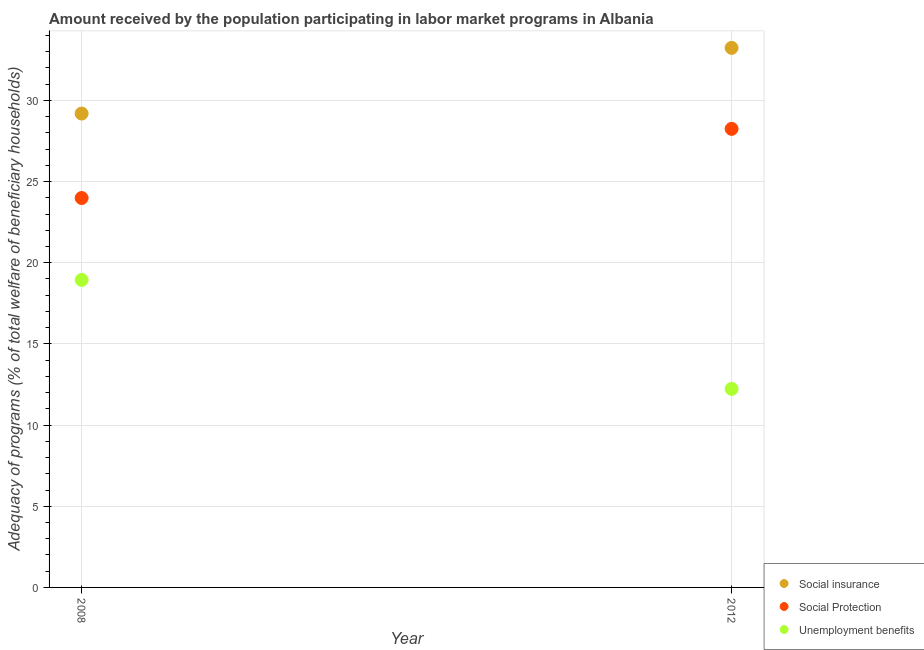What is the amount received by the population participating in social insurance programs in 2008?
Your answer should be compact. 29.19. Across all years, what is the maximum amount received by the population participating in social insurance programs?
Give a very brief answer. 33.23. Across all years, what is the minimum amount received by the population participating in social protection programs?
Offer a very short reply. 23.99. In which year was the amount received by the population participating in social protection programs maximum?
Offer a terse response. 2012. What is the total amount received by the population participating in unemployment benefits programs in the graph?
Give a very brief answer. 31.17. What is the difference between the amount received by the population participating in social insurance programs in 2008 and that in 2012?
Provide a succinct answer. -4.05. What is the difference between the amount received by the population participating in social insurance programs in 2012 and the amount received by the population participating in unemployment benefits programs in 2008?
Offer a very short reply. 14.29. What is the average amount received by the population participating in unemployment benefits programs per year?
Offer a very short reply. 15.58. In the year 2008, what is the difference between the amount received by the population participating in unemployment benefits programs and amount received by the population participating in social insurance programs?
Offer a terse response. -10.24. What is the ratio of the amount received by the population participating in unemployment benefits programs in 2008 to that in 2012?
Your answer should be compact. 1.55. Is the amount received by the population participating in unemployment benefits programs in 2008 less than that in 2012?
Keep it short and to the point. No. In how many years, is the amount received by the population participating in social insurance programs greater than the average amount received by the population participating in social insurance programs taken over all years?
Keep it short and to the point. 1. Is the amount received by the population participating in unemployment benefits programs strictly greater than the amount received by the population participating in social protection programs over the years?
Offer a very short reply. No. Is the amount received by the population participating in social insurance programs strictly less than the amount received by the population participating in social protection programs over the years?
Offer a terse response. No. How many years are there in the graph?
Offer a very short reply. 2. What is the difference between two consecutive major ticks on the Y-axis?
Your answer should be compact. 5. Are the values on the major ticks of Y-axis written in scientific E-notation?
Give a very brief answer. No. Does the graph contain any zero values?
Provide a succinct answer. No. What is the title of the graph?
Give a very brief answer. Amount received by the population participating in labor market programs in Albania. What is the label or title of the X-axis?
Keep it short and to the point. Year. What is the label or title of the Y-axis?
Your response must be concise. Adequacy of programs (% of total welfare of beneficiary households). What is the Adequacy of programs (% of total welfare of beneficiary households) of Social insurance in 2008?
Your answer should be compact. 29.19. What is the Adequacy of programs (% of total welfare of beneficiary households) in Social Protection in 2008?
Give a very brief answer. 23.99. What is the Adequacy of programs (% of total welfare of beneficiary households) of Unemployment benefits in 2008?
Your answer should be very brief. 18.94. What is the Adequacy of programs (% of total welfare of beneficiary households) in Social insurance in 2012?
Provide a succinct answer. 33.23. What is the Adequacy of programs (% of total welfare of beneficiary households) of Social Protection in 2012?
Provide a succinct answer. 28.24. What is the Adequacy of programs (% of total welfare of beneficiary households) of Unemployment benefits in 2012?
Ensure brevity in your answer.  12.23. Across all years, what is the maximum Adequacy of programs (% of total welfare of beneficiary households) in Social insurance?
Your answer should be compact. 33.23. Across all years, what is the maximum Adequacy of programs (% of total welfare of beneficiary households) of Social Protection?
Keep it short and to the point. 28.24. Across all years, what is the maximum Adequacy of programs (% of total welfare of beneficiary households) in Unemployment benefits?
Your answer should be very brief. 18.94. Across all years, what is the minimum Adequacy of programs (% of total welfare of beneficiary households) of Social insurance?
Your response must be concise. 29.19. Across all years, what is the minimum Adequacy of programs (% of total welfare of beneficiary households) in Social Protection?
Offer a very short reply. 23.99. Across all years, what is the minimum Adequacy of programs (% of total welfare of beneficiary households) of Unemployment benefits?
Offer a very short reply. 12.23. What is the total Adequacy of programs (% of total welfare of beneficiary households) of Social insurance in the graph?
Keep it short and to the point. 62.42. What is the total Adequacy of programs (% of total welfare of beneficiary households) of Social Protection in the graph?
Keep it short and to the point. 52.23. What is the total Adequacy of programs (% of total welfare of beneficiary households) of Unemployment benefits in the graph?
Offer a very short reply. 31.17. What is the difference between the Adequacy of programs (% of total welfare of beneficiary households) in Social insurance in 2008 and that in 2012?
Make the answer very short. -4.05. What is the difference between the Adequacy of programs (% of total welfare of beneficiary households) of Social Protection in 2008 and that in 2012?
Offer a very short reply. -4.26. What is the difference between the Adequacy of programs (% of total welfare of beneficiary households) of Unemployment benefits in 2008 and that in 2012?
Offer a terse response. 6.71. What is the difference between the Adequacy of programs (% of total welfare of beneficiary households) of Social insurance in 2008 and the Adequacy of programs (% of total welfare of beneficiary households) of Social Protection in 2012?
Offer a terse response. 0.94. What is the difference between the Adequacy of programs (% of total welfare of beneficiary households) in Social insurance in 2008 and the Adequacy of programs (% of total welfare of beneficiary households) in Unemployment benefits in 2012?
Keep it short and to the point. 16.96. What is the difference between the Adequacy of programs (% of total welfare of beneficiary households) in Social Protection in 2008 and the Adequacy of programs (% of total welfare of beneficiary households) in Unemployment benefits in 2012?
Offer a very short reply. 11.76. What is the average Adequacy of programs (% of total welfare of beneficiary households) of Social insurance per year?
Offer a terse response. 31.21. What is the average Adequacy of programs (% of total welfare of beneficiary households) in Social Protection per year?
Offer a very short reply. 26.11. What is the average Adequacy of programs (% of total welfare of beneficiary households) of Unemployment benefits per year?
Make the answer very short. 15.58. In the year 2008, what is the difference between the Adequacy of programs (% of total welfare of beneficiary households) in Social insurance and Adequacy of programs (% of total welfare of beneficiary households) in Social Protection?
Provide a succinct answer. 5.2. In the year 2008, what is the difference between the Adequacy of programs (% of total welfare of beneficiary households) of Social insurance and Adequacy of programs (% of total welfare of beneficiary households) of Unemployment benefits?
Your answer should be compact. 10.24. In the year 2008, what is the difference between the Adequacy of programs (% of total welfare of beneficiary households) of Social Protection and Adequacy of programs (% of total welfare of beneficiary households) of Unemployment benefits?
Offer a terse response. 5.04. In the year 2012, what is the difference between the Adequacy of programs (% of total welfare of beneficiary households) in Social insurance and Adequacy of programs (% of total welfare of beneficiary households) in Social Protection?
Provide a succinct answer. 4.99. In the year 2012, what is the difference between the Adequacy of programs (% of total welfare of beneficiary households) in Social insurance and Adequacy of programs (% of total welfare of beneficiary households) in Unemployment benefits?
Provide a short and direct response. 21.01. In the year 2012, what is the difference between the Adequacy of programs (% of total welfare of beneficiary households) in Social Protection and Adequacy of programs (% of total welfare of beneficiary households) in Unemployment benefits?
Make the answer very short. 16.02. What is the ratio of the Adequacy of programs (% of total welfare of beneficiary households) in Social insurance in 2008 to that in 2012?
Your answer should be very brief. 0.88. What is the ratio of the Adequacy of programs (% of total welfare of beneficiary households) in Social Protection in 2008 to that in 2012?
Make the answer very short. 0.85. What is the ratio of the Adequacy of programs (% of total welfare of beneficiary households) of Unemployment benefits in 2008 to that in 2012?
Give a very brief answer. 1.55. What is the difference between the highest and the second highest Adequacy of programs (% of total welfare of beneficiary households) in Social insurance?
Keep it short and to the point. 4.05. What is the difference between the highest and the second highest Adequacy of programs (% of total welfare of beneficiary households) in Social Protection?
Your answer should be very brief. 4.26. What is the difference between the highest and the second highest Adequacy of programs (% of total welfare of beneficiary households) in Unemployment benefits?
Offer a very short reply. 6.71. What is the difference between the highest and the lowest Adequacy of programs (% of total welfare of beneficiary households) of Social insurance?
Ensure brevity in your answer.  4.05. What is the difference between the highest and the lowest Adequacy of programs (% of total welfare of beneficiary households) of Social Protection?
Give a very brief answer. 4.26. What is the difference between the highest and the lowest Adequacy of programs (% of total welfare of beneficiary households) in Unemployment benefits?
Give a very brief answer. 6.71. 